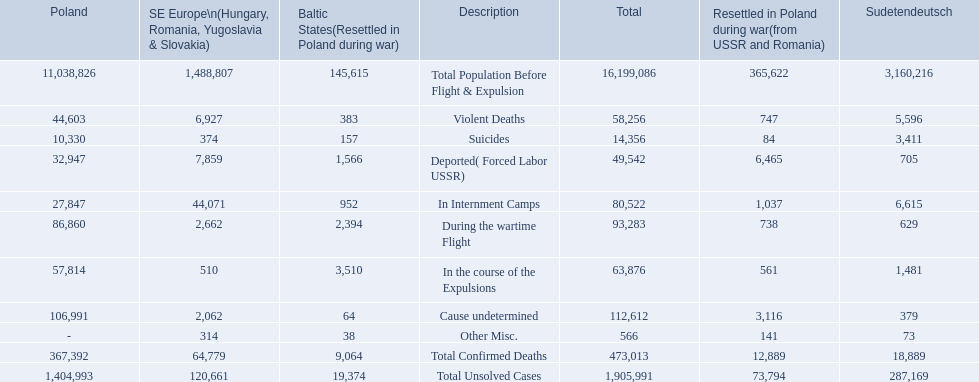How many total confirmed deaths were there in the baltic states? 9,064. How many deaths had an undetermined cause? 64. How many deaths in that region were miscellaneous? 38. Were there more deaths from an undetermined cause or that were listed as miscellaneous? Cause undetermined. 